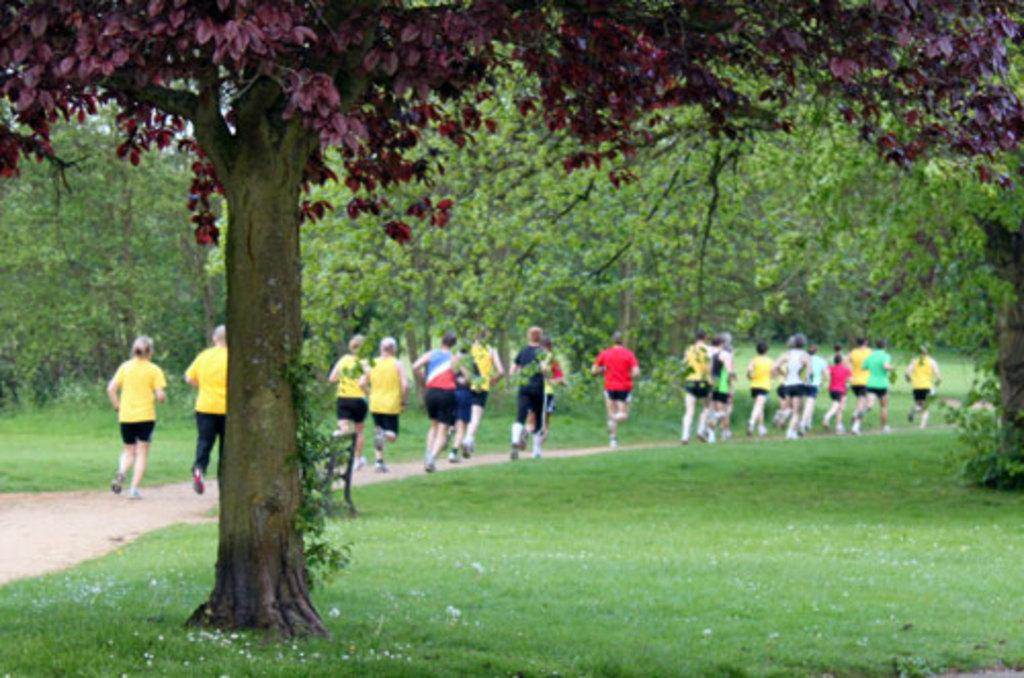What is happening in the image involving the group of people? The people in the image are running. What are the people wearing? The people are wearing multi-color dresses. What can be seen in the background of the image? There are trees and the sky visible in the background. What is the color of the trees in the image? The trees are green. What is the color of the sky in the image? The sky is white in color. Can you tell me how many volleyballs are being used by the group of people in the image? There are no volleyballs present in the image; the people are running. Is there an argument happening between the people in the image? There is no indication of an argument in the image; the people are running. 